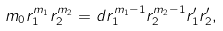<formula> <loc_0><loc_0><loc_500><loc_500>m _ { 0 } r _ { 1 } ^ { m _ { 1 } } r _ { 2 } ^ { m _ { 2 } } = d r _ { 1 } ^ { m _ { 1 } - 1 } r _ { 2 } ^ { m _ { 2 } - 1 } r ^ { \prime } _ { 1 } r ^ { \prime } _ { 2 } ,</formula> 